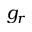<formula> <loc_0><loc_0><loc_500><loc_500>g _ { r }</formula> 